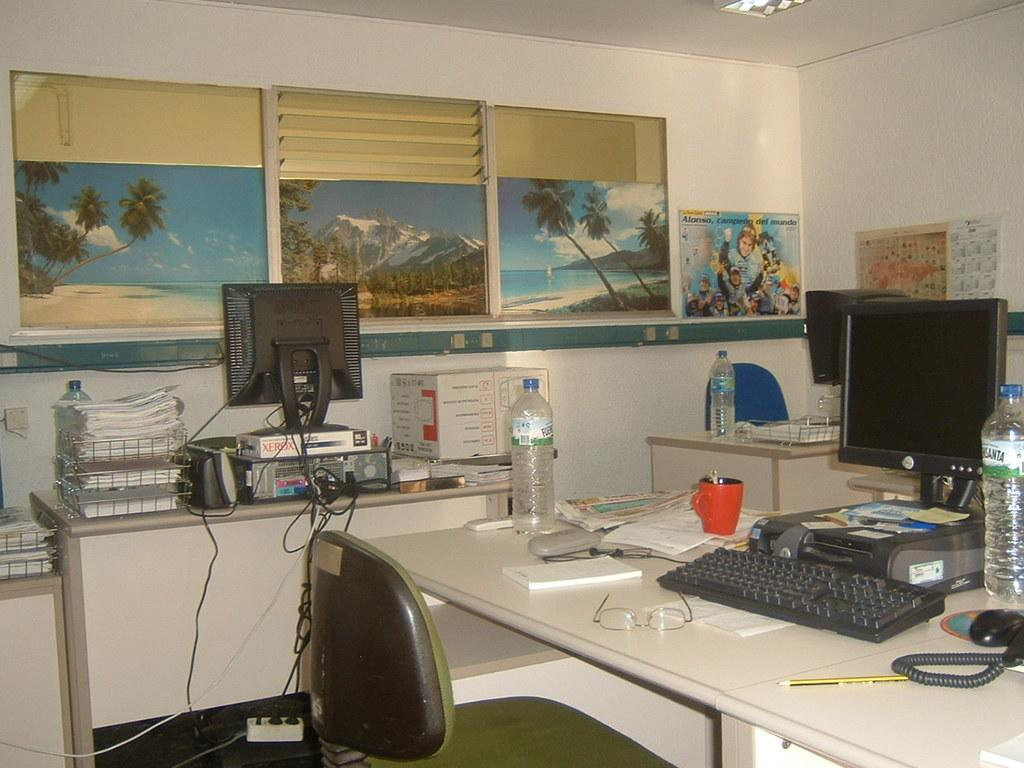<image>
Give a short and clear explanation of the subsequent image. The computer screen on the left is sitting on a xerox box. 